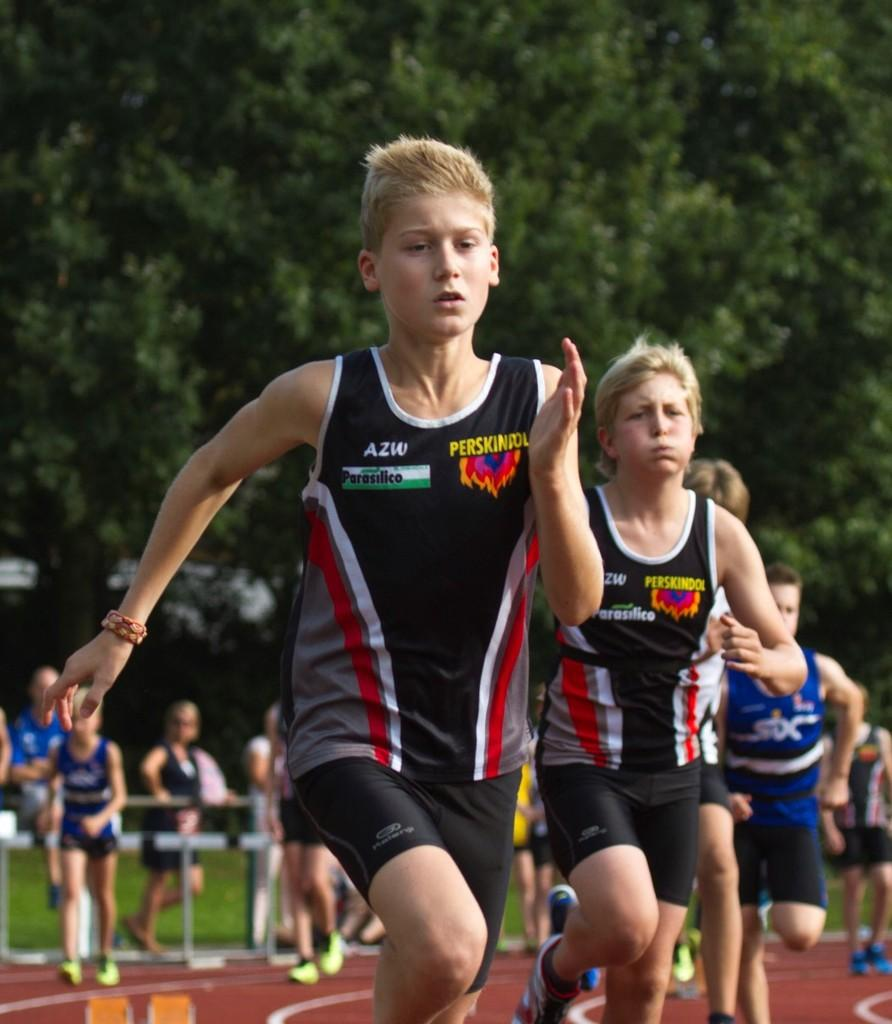<image>
Write a terse but informative summary of the picture. a person that has a shirt that has AZW on their jersey 